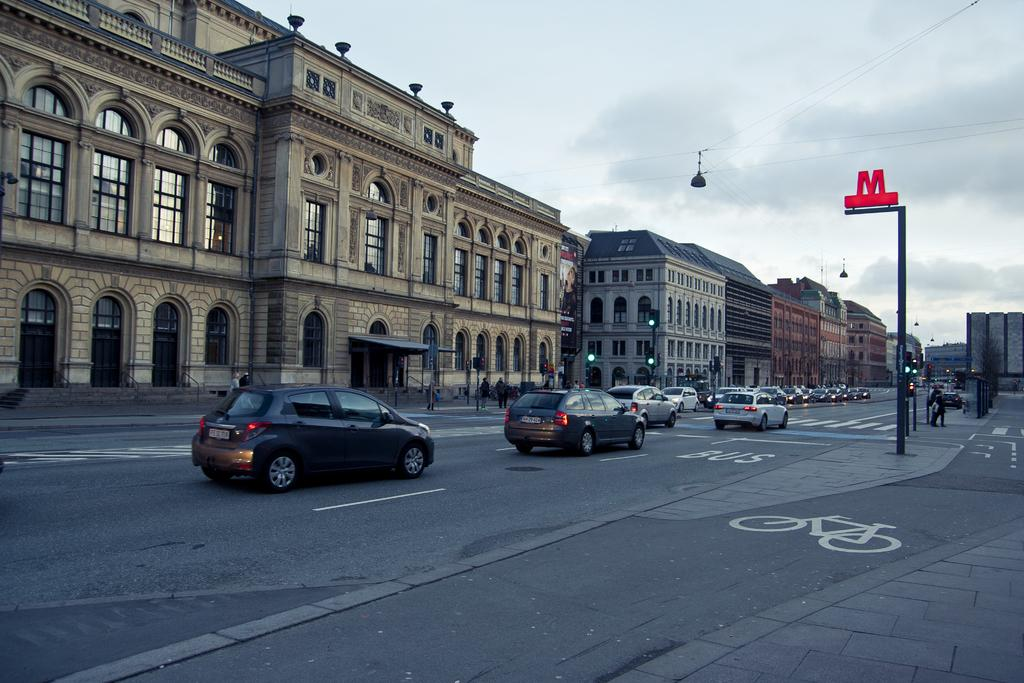What is happening on the road in the image? There are cars on a road in the image. What can be seen besides the road and cars? There is a pole in the image. What is happening in the background? There are people walking on a footpath and buildings visible in the background of the image. What can be seen in the sky in the image? The sky is visible in the background of the image. How many rings are visible on the pole in the image? There are no rings visible on the pole in the image. What type of crow is perched on the car in the image? There is no crow present in the image. 